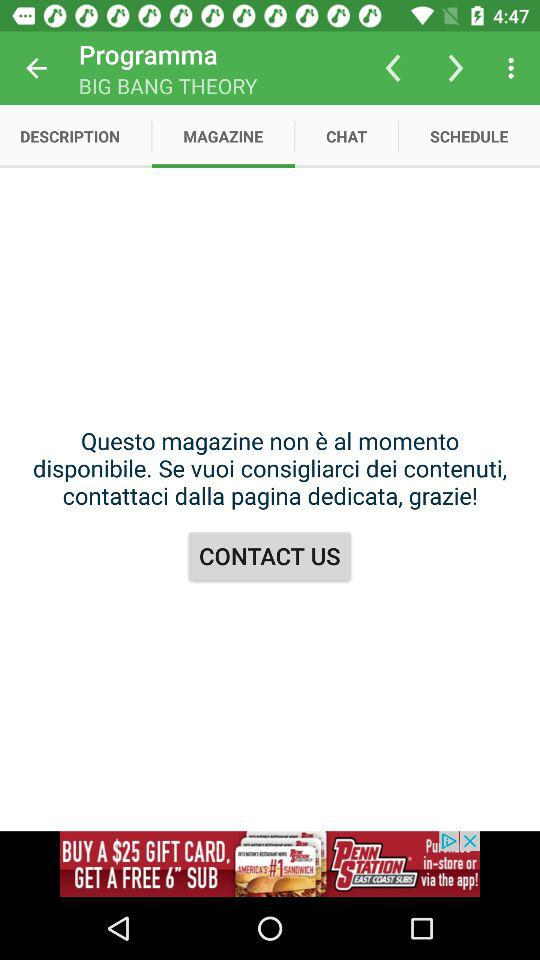Who is in the chat?
When the provided information is insufficient, respond with <no answer>. <no answer> 